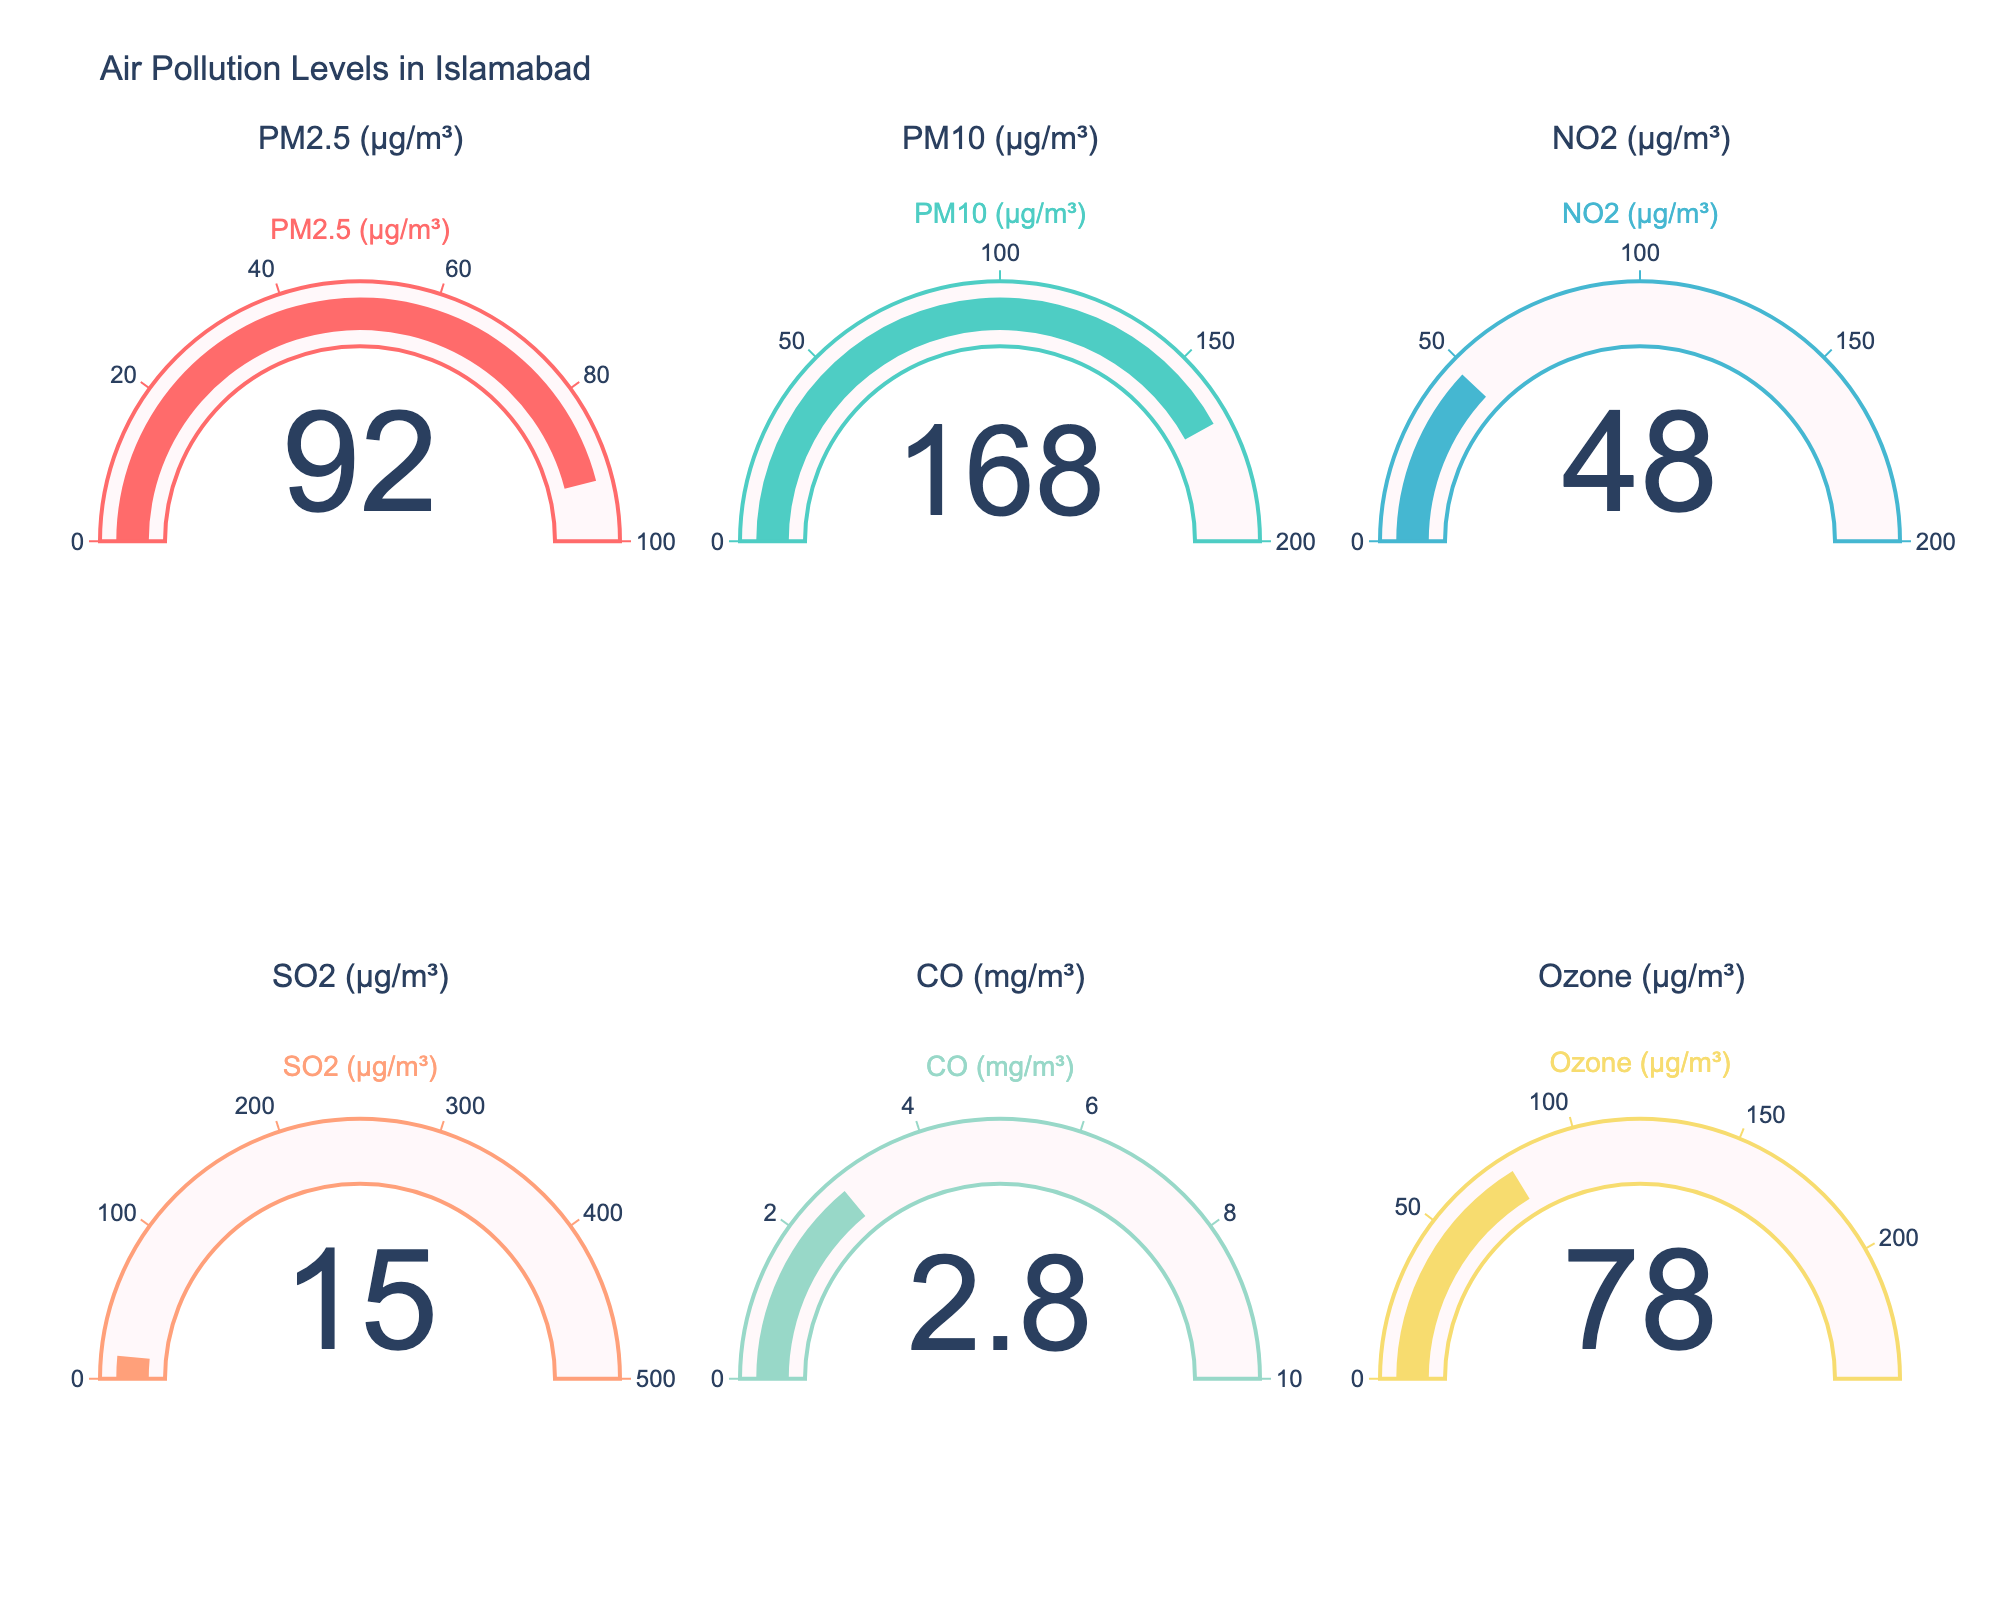What is the value of PM2.5 in the gauge chart? The gauge for PM2.5 is labeled and displays a value in μg/m³. Looking at the chart, the value of PM2.5 is read directly from the figure.
Answer: 92 Between PM10 and NO2, which has the higher value? Compare the values of PM10 and NO2 from their respective gauges. PM10 shows 168 μg/m³, while NO2 shows 48 μg/m³.
Answer: PM10 What is the difference between the values of CO and SO2? Subtract the value of SO2 from the value of CO. CO is 2.8 mg/m³ and SO2 is 15 μg/m³. Converting CO to μg/m³ (1 mg/m³ = 1000 μg/m³), so 2800 μg/m³ - 15 μg/m³ = 2785 μg/m³.
Answer: 2785 μg/m³ Which pollutant has the lowest value in the chart? Identify the gauge with the smallest displayed number. The values are PM2.5: 92, PM10: 168, NO2: 48, SO2: 15, CO: 2.8 mg/m³ (2800), Ozone: 78. SO2 has the smallest value of 15 μg/m³.
Answer: SO2 How much higher is the PM10 value compared to the WHO maximum limit for PM2.5? First, identify the WHO maximum limit for PM2.5, which is 100 μg/m³. Then, subtract this limit from the PM10 value, 168 - 100 = 68 μg/m³.
Answer: 68 μg/m³ If the values of NO2 and CO were added together, what would be the total? Convert CO to μg/m³ first (2.8 mg/m³ = 2800 μg/m³), then add NO2: 48 μg/m³ and CO: 2800 μg/m³. 2800 + 48 = 2848 μg/m³.
Answer: 2848 μg/m³ Which pollution level is closest to its maximum limit? Calculate the percentage for each value compared to its maximum limit: PM2.5: 92/100 = 92%, PM10: 168/200 = 84%, NO2: 48/200 = 24%, SO2: 15/500 = 3%, CO: 2.8/10 = 28%, Ozone: 78/240 = 32.5%. The PM2.5 value of 92% is the highest percentage.
Answer: PM2.5 What is the average value of the displayed air pollutants? Sum all the values and divide by the number of pollutants: (92 + 168 + 48 + 15 + 2800 + 78) / 6 = 3201 / 6 ≈ 533.5 μg/m³.
Answer: 533.5 μg/m³ Which pollutant's value falls below its maximum limit by the widest margin? Calculate the difference between each value and its maximum limit: PM2.5: 100 - 92 = 8, PM10: 200 - 168 = 32, NO2: 200 - 48 = 152, SO2: 500 - 15 = 485, CO: 10 - 2.8 = 7.2 (7200 μg/m³ - 2800 μg/m³ = 4400 μg/m³), Ozone: 240 - 78 = 162. The SO2 has the widest margin.
Answer: SO2 